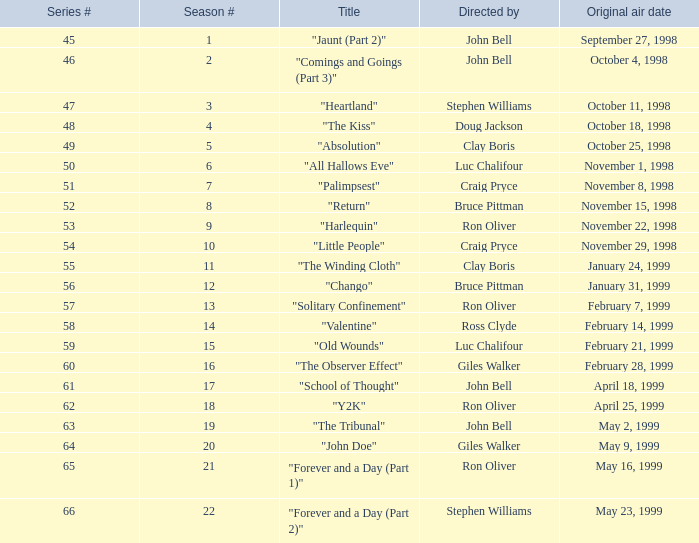Which season # has a title referred to as "jaunt (part 2)", and a series # more than 45? None. 